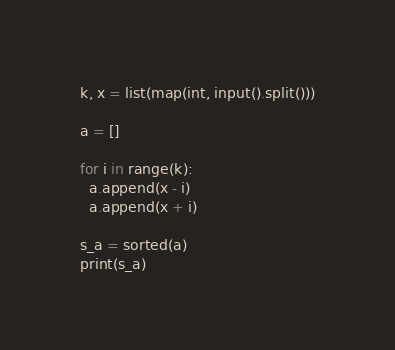Convert code to text. <code><loc_0><loc_0><loc_500><loc_500><_Python_>k, x = list(map(int, input().split()))

a = []

for i in range(k):
  a.append(x - i)
  a.append(x + i)

s_a = sorted(a)
print(s_a)</code> 